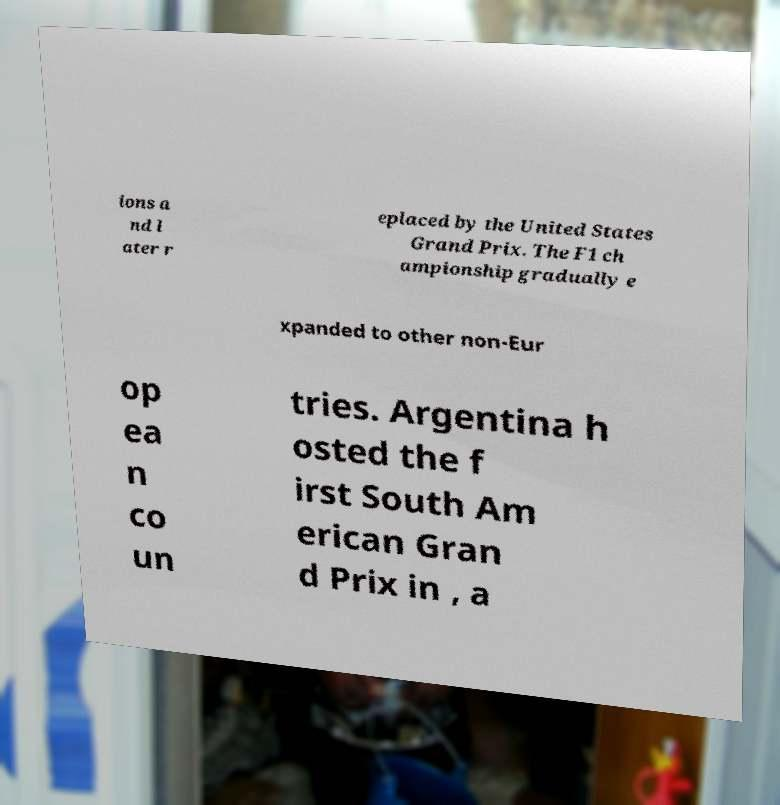Can you read and provide the text displayed in the image?This photo seems to have some interesting text. Can you extract and type it out for me? ions a nd l ater r eplaced by the United States Grand Prix. The F1 ch ampionship gradually e xpanded to other non-Eur op ea n co un tries. Argentina h osted the f irst South Am erican Gran d Prix in , a 